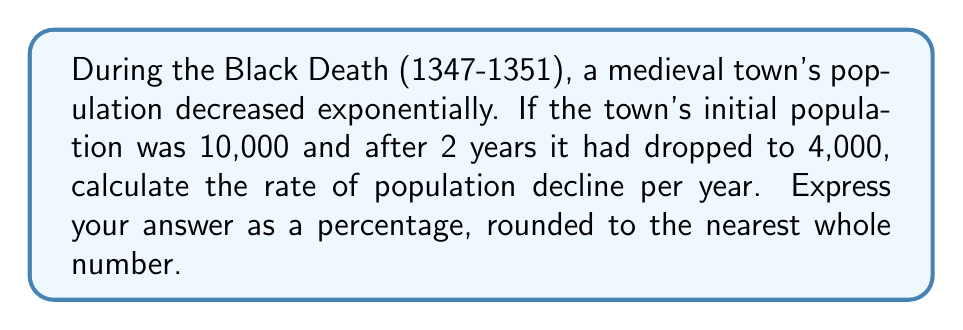Teach me how to tackle this problem. Let's approach this step-by-step:

1) We can model this exponential decline using the formula:

   $$P(t) = P_0 \cdot e^{rt}$$

   Where:
   $P(t)$ is the population at time $t$
   $P_0$ is the initial population
   $r$ is the rate of decline (what we're solving for)
   $t$ is the time in years

2) We know:
   $P_0 = 10,000$
   $P(2) = 4,000$ (after 2 years)
   $t = 2$

3) Let's plug these into our equation:

   $$4,000 = 10,000 \cdot e^{2r}$$

4) Divide both sides by 10,000:

   $$0.4 = e^{2r}$$

5) Take the natural log of both sides:

   $$\ln(0.4) = 2r$$

6) Solve for $r$:

   $$r = \frac{\ln(0.4)}{2} \approx -0.4595$$

7) This is the exponential rate of decline. To convert to a percentage, multiply by 100:

   $$-0.4595 \cdot 100 \approx -45.95\%$$

8) Rounding to the nearest whole number:

   $$-46\%$$
Answer: $-46\%$ 